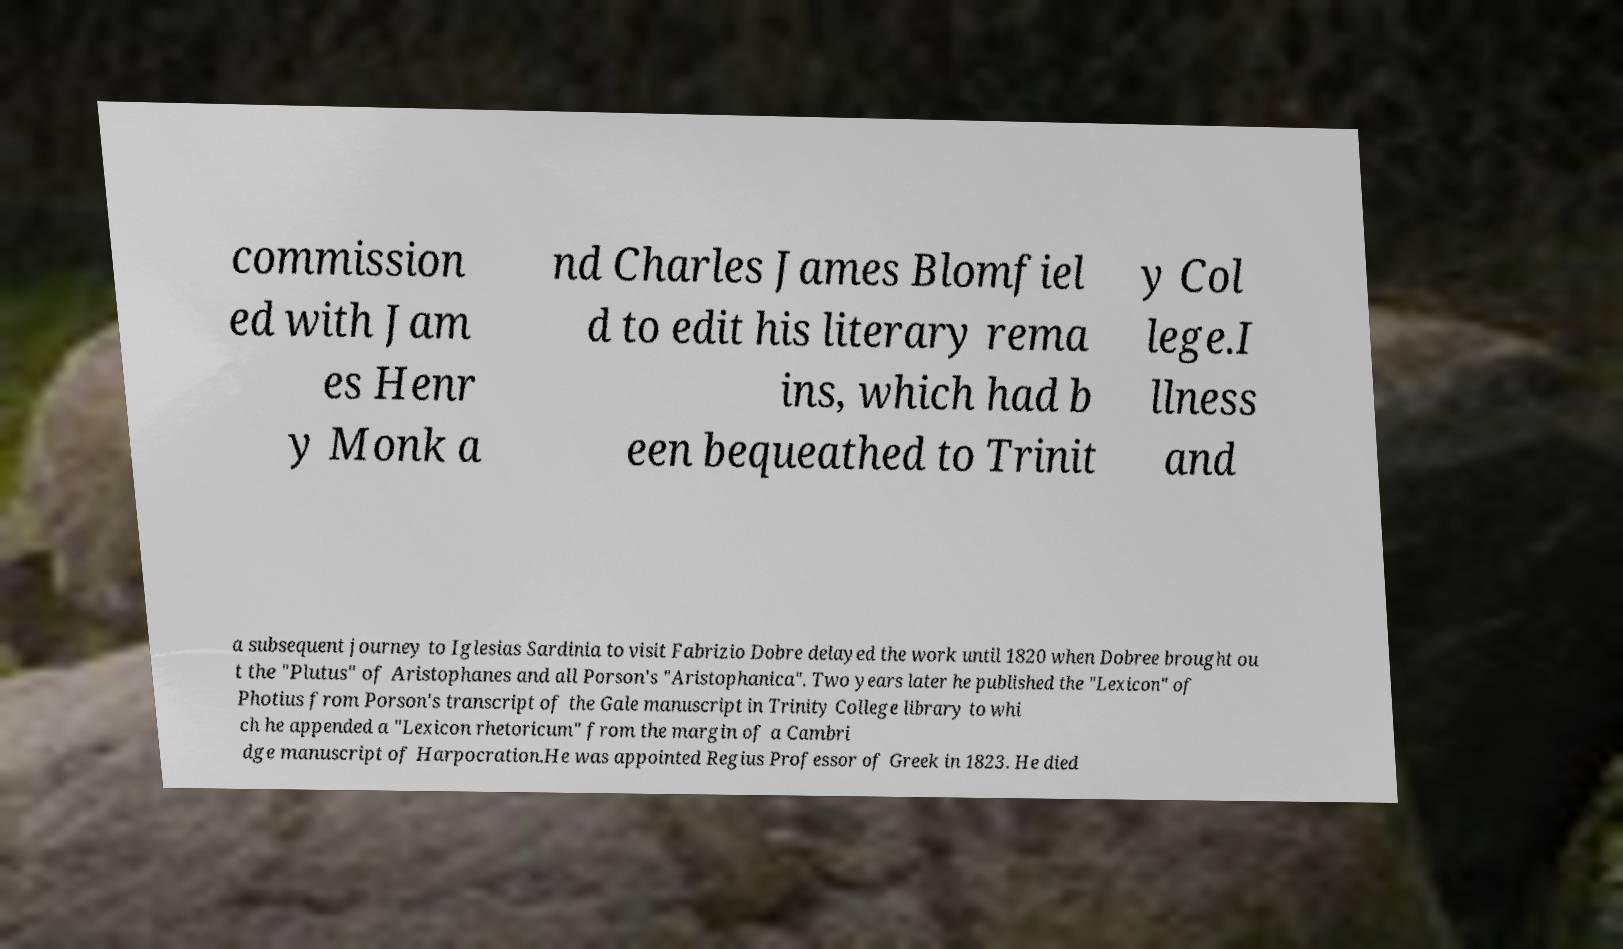What messages or text are displayed in this image? I need them in a readable, typed format. commission ed with Jam es Henr y Monk a nd Charles James Blomfiel d to edit his literary rema ins, which had b een bequeathed to Trinit y Col lege.I llness and a subsequent journey to Iglesias Sardinia to visit Fabrizio Dobre delayed the work until 1820 when Dobree brought ou t the "Plutus" of Aristophanes and all Porson's "Aristophanica". Two years later he published the "Lexicon" of Photius from Porson's transcript of the Gale manuscript in Trinity College library to whi ch he appended a "Lexicon rhetoricum" from the margin of a Cambri dge manuscript of Harpocration.He was appointed Regius Professor of Greek in 1823. He died 